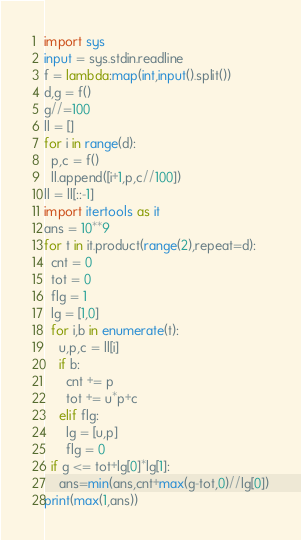<code> <loc_0><loc_0><loc_500><loc_500><_Python_>import sys
input = sys.stdin.readline
f = lambda:map(int,input().split())
d,g = f()
g//=100
ll = []
for i in range(d):
  p,c = f()
  ll.append([i+1,p,c//100])
ll = ll[::-1]
import itertools as it
ans = 10**9
for t in it.product(range(2),repeat=d):
  cnt = 0
  tot = 0
  flg = 1
  lg = [1,0]
  for i,b in enumerate(t):
    u,p,c = ll[i]
    if b:
      cnt += p
      tot += u*p+c
    elif flg:
      lg = [u,p]
      flg = 0
  if g <= tot+lg[0]*lg[1]:
    ans=min(ans,cnt+max(g-tot,0)//lg[0])
print(max(1,ans))</code> 